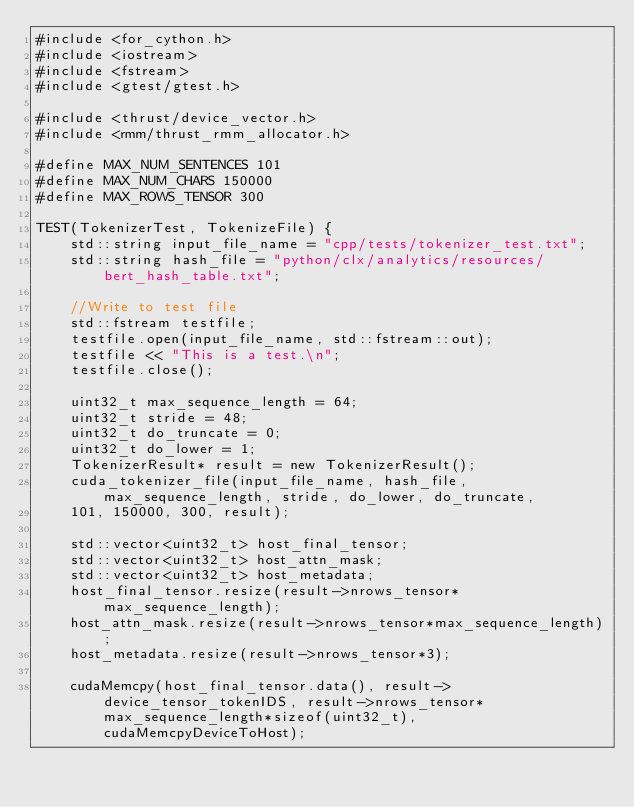Convert code to text. <code><loc_0><loc_0><loc_500><loc_500><_Cuda_>#include <for_cython.h>
#include <iostream>
#include <fstream>
#include <gtest/gtest.h>

#include <thrust/device_vector.h>
#include <rmm/thrust_rmm_allocator.h>

#define MAX_NUM_SENTENCES 101
#define MAX_NUM_CHARS 150000
#define MAX_ROWS_TENSOR 300

TEST(TokenizerTest, TokenizeFile) {
    std::string input_file_name = "cpp/tests/tokenizer_test.txt";
    std::string hash_file = "python/clx/analytics/resources/bert_hash_table.txt";

    //Write to test file
    std::fstream testfile;
    testfile.open(input_file_name, std::fstream::out);
    testfile << "This is a test.\n";
    testfile.close();

    uint32_t max_sequence_length = 64;
    uint32_t stride = 48;
    uint32_t do_truncate = 0;
    uint32_t do_lower = 1;
    TokenizerResult* result = new TokenizerResult();
    cuda_tokenizer_file(input_file_name, hash_file, max_sequence_length, stride, do_lower, do_truncate,
    101, 150000, 300, result);

    std::vector<uint32_t> host_final_tensor;
    std::vector<uint32_t> host_attn_mask;
    std::vector<uint32_t> host_metadata;
    host_final_tensor.resize(result->nrows_tensor*max_sequence_length);
    host_attn_mask.resize(result->nrows_tensor*max_sequence_length);
    host_metadata.resize(result->nrows_tensor*3);

    cudaMemcpy(host_final_tensor.data(), result->device_tensor_tokenIDS, result->nrows_tensor*max_sequence_length*sizeof(uint32_t), cudaMemcpyDeviceToHost);</code> 